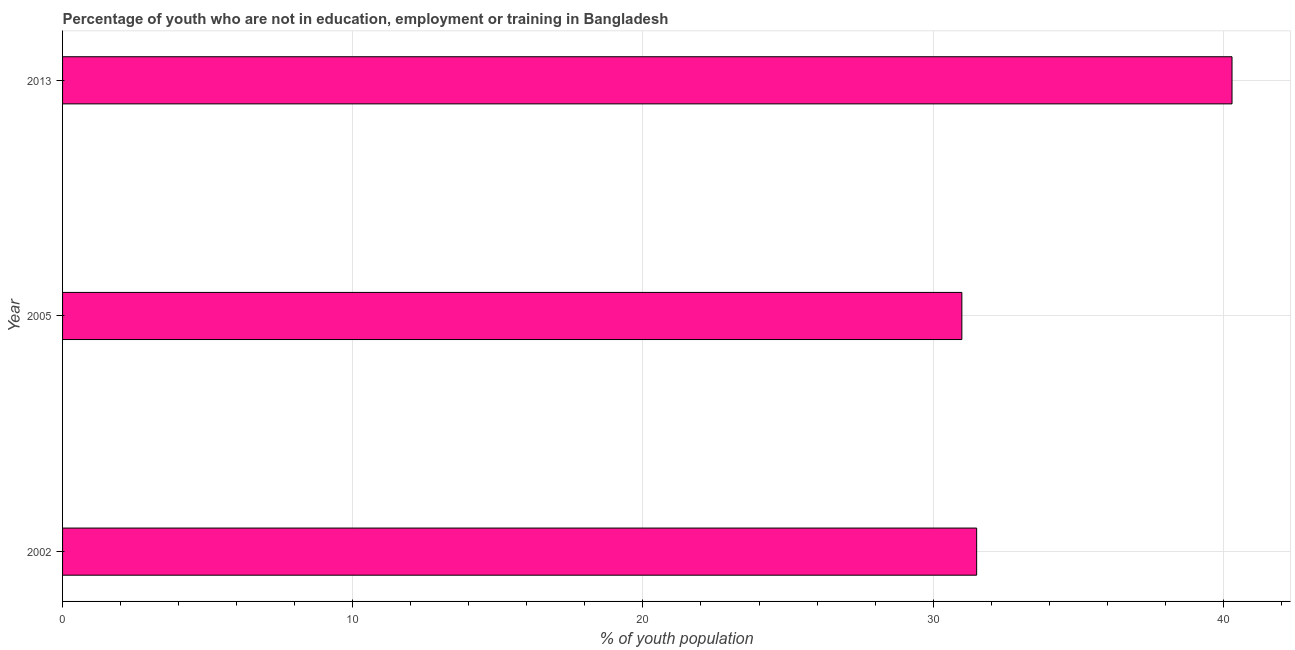Does the graph contain grids?
Keep it short and to the point. Yes. What is the title of the graph?
Offer a terse response. Percentage of youth who are not in education, employment or training in Bangladesh. What is the label or title of the X-axis?
Your response must be concise. % of youth population. What is the unemployed youth population in 2005?
Make the answer very short. 30.99. Across all years, what is the maximum unemployed youth population?
Give a very brief answer. 40.3. Across all years, what is the minimum unemployed youth population?
Your response must be concise. 30.99. In which year was the unemployed youth population minimum?
Provide a succinct answer. 2005. What is the sum of the unemployed youth population?
Your answer should be compact. 102.79. What is the difference between the unemployed youth population in 2002 and 2013?
Keep it short and to the point. -8.8. What is the average unemployed youth population per year?
Provide a succinct answer. 34.26. What is the median unemployed youth population?
Make the answer very short. 31.5. Do a majority of the years between 2002 and 2013 (inclusive) have unemployed youth population greater than 40 %?
Your response must be concise. No. What is the ratio of the unemployed youth population in 2002 to that in 2005?
Your answer should be compact. 1.02. Is the unemployed youth population in 2002 less than that in 2013?
Provide a short and direct response. Yes. What is the difference between the highest and the lowest unemployed youth population?
Provide a short and direct response. 9.31. How many bars are there?
Your answer should be compact. 3. Are all the bars in the graph horizontal?
Your response must be concise. Yes. How many years are there in the graph?
Offer a very short reply. 3. What is the difference between two consecutive major ticks on the X-axis?
Your answer should be compact. 10. What is the % of youth population of 2002?
Make the answer very short. 31.5. What is the % of youth population in 2005?
Keep it short and to the point. 30.99. What is the % of youth population in 2013?
Your answer should be compact. 40.3. What is the difference between the % of youth population in 2002 and 2005?
Offer a terse response. 0.51. What is the difference between the % of youth population in 2002 and 2013?
Give a very brief answer. -8.8. What is the difference between the % of youth population in 2005 and 2013?
Offer a terse response. -9.31. What is the ratio of the % of youth population in 2002 to that in 2005?
Your answer should be very brief. 1.02. What is the ratio of the % of youth population in 2002 to that in 2013?
Your answer should be compact. 0.78. What is the ratio of the % of youth population in 2005 to that in 2013?
Give a very brief answer. 0.77. 